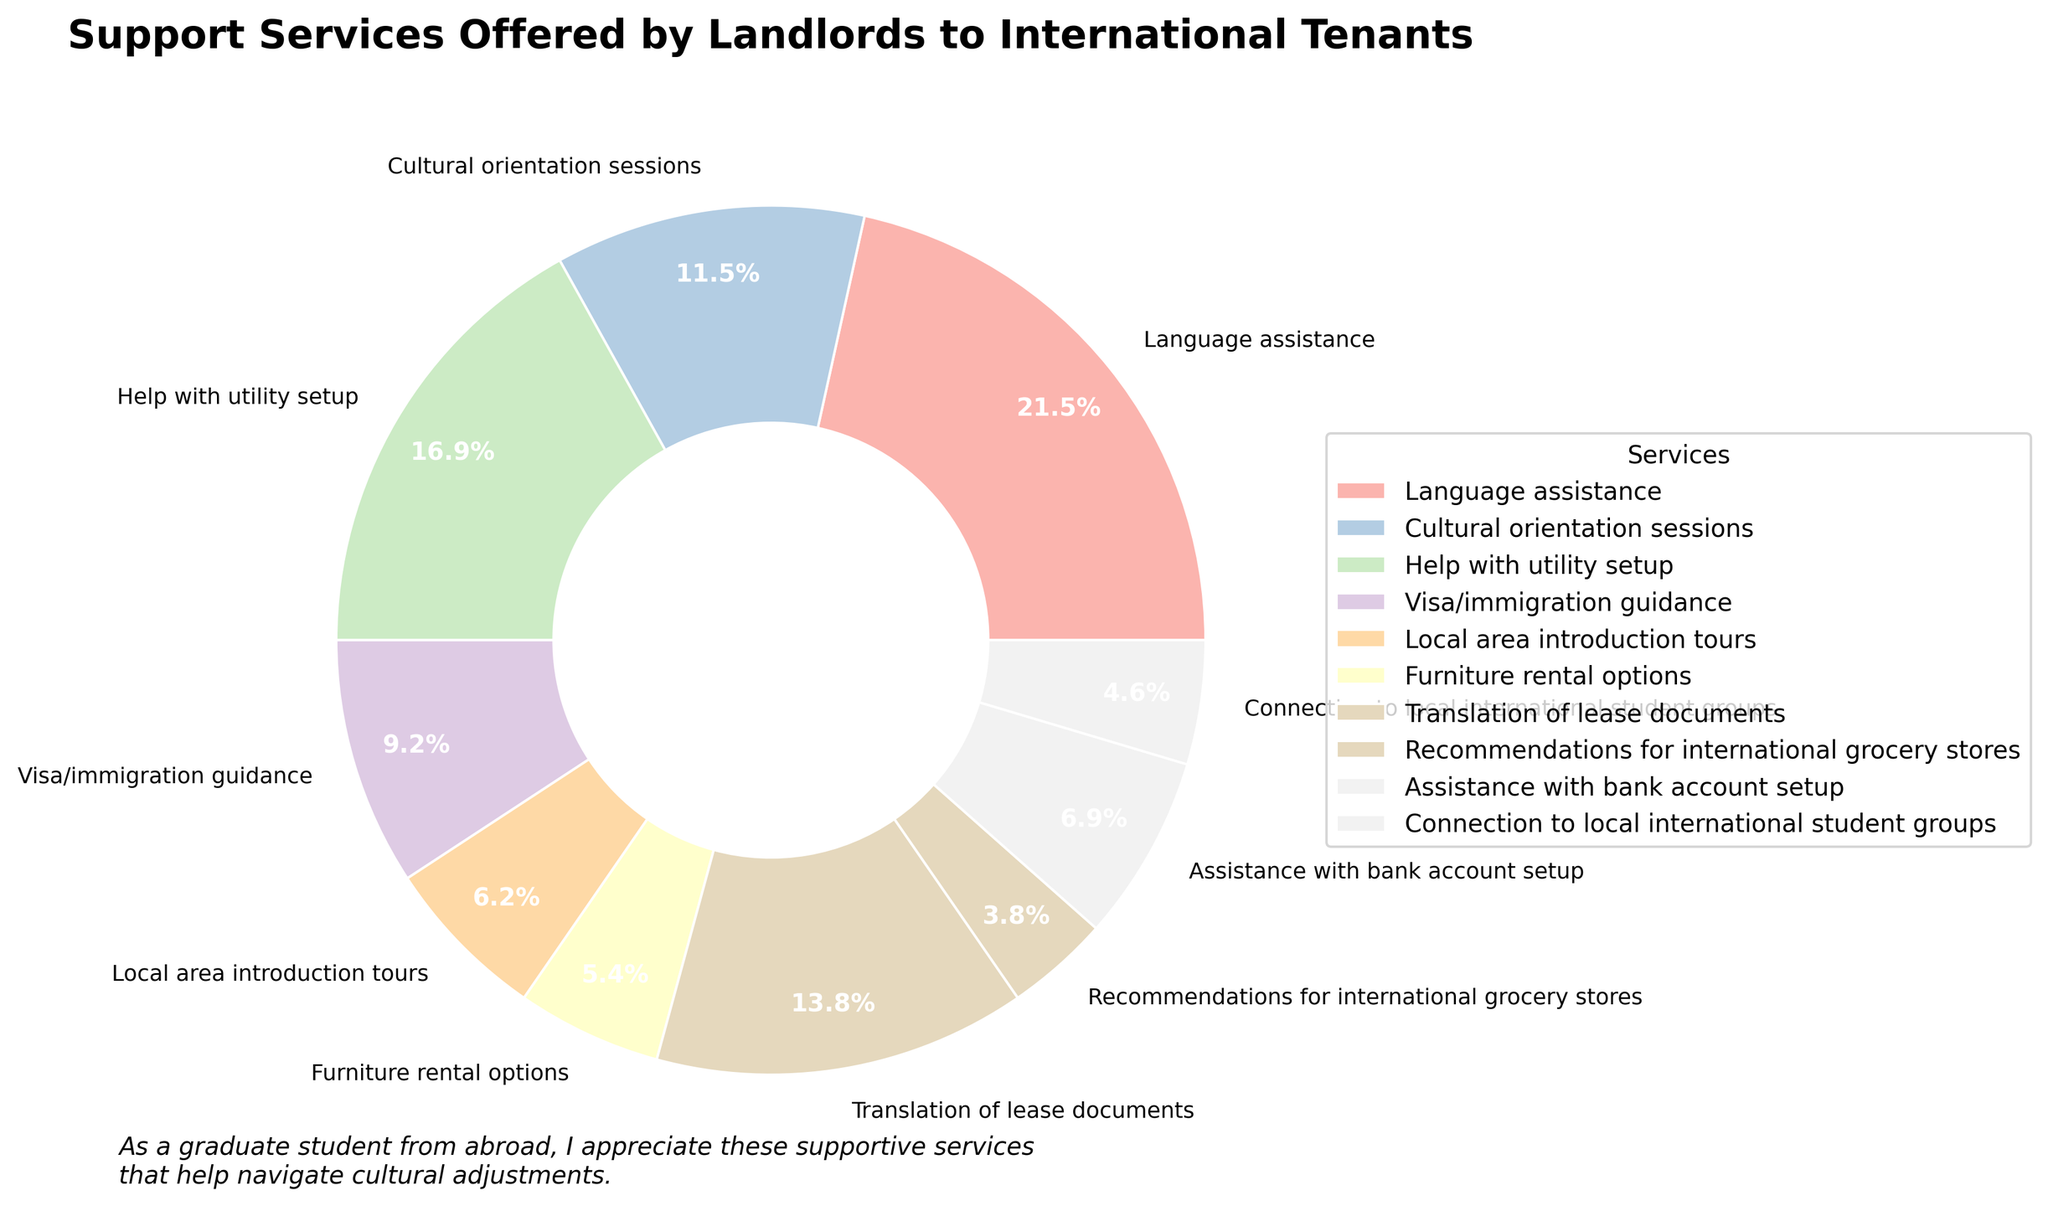What percentage of landlords offer help with utility setup compared to those offering translation of lease documents? From the figure, help with utility setup is 22% and translation of lease documents is 18%. The comparison shows that help with utility setup is provided by a higher percentage of landlords.
Answer: Help with utility setup is 22% and translation of lease documents is 18% Which support service has the lowest percentage of landlords offering it, and what is that percentage? By analyzing the pie chart, we see that 'Recommendations for international grocery stores' has the smallest wedge, indicating the lowest percentage at 5%.
Answer: Recommendations for international grocery stores at 5% Which service is more commonly offered: cultural orientation sessions or local area introduction tours? From the figure, cultural orientation sessions are offered by 15% of landlords, whereas local area introduction tours are offered by 8%. Therefore, cultural orientation sessions are more common.
Answer: Cultural orientation sessions What is the combined percentage of landlords offering visa/immigration guidance and assistance with bank account setup? The figure shows visa/immigration guidance at 12% and assistance with bank account setup at 9%. Adding these, 12% + 9% = 21%.
Answer: 21% How does the percentage of landlords offering language assistance compare to those offering furniture rental options? Language assistance is offered by 28% of landlords, whereas furniture rental options are offered by 7%. Thus, language assistance is significantly higher.
Answer: Language assistance (28%) is higher than furniture rental options (7%) What two services have the closest percentage values, and what are those percentages? Observing the figure, help with utility setup (22%) and translation of lease documents (18%) are relatively close in value, with only a 4% difference.
Answer: Help with utility setup (22%) and translation of lease documents (18%) How do the support services offered by landlords relate to cultural adjustments? The figure highlights various services, such as language assistance (28%) and cultural orientation sessions (15%), which are especially important for helping international tenants adjust culturally. These services directly cater to cultural integration needs.
Answer: They directly cater to cultural integration needs What is the most common support service offered by landlords to international tenants, and why might that be important? Language assistance is the most common service at 28%. This is crucial for international tenants who might face language barriers when integrating into a new country.
Answer: Language assistance at 28% If you add up the percentages for services related to initial settlement (help with utility setup, visa/immigration guidance, assistance with bank account setup) and compare that to the total for services related to ongoing support (local area introduction tours, recommendations for international grocery stores, connection to local international student groups), which is higher? Initial settlement services: help with utility setup (22%), visa/immigration guidance (12%), assistance with bank account setup (9%) total 43%. Ongoing support: local area introduction tours (8%), recommendations for international grocery stores (5%), connection to local international student groups (6%) total 19%. The initial settlement services are higher.
Answer: Initial settlement services at 43% 